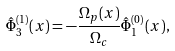<formula> <loc_0><loc_0><loc_500><loc_500>\hat { \Phi } _ { 3 } ^ { ( 1 ) } ( x ) = - \frac { \Omega _ { p } ( x ) } { \Omega _ { c } } \hat { \Phi } _ { 1 } ^ { ( 0 ) } ( x ) ,</formula> 